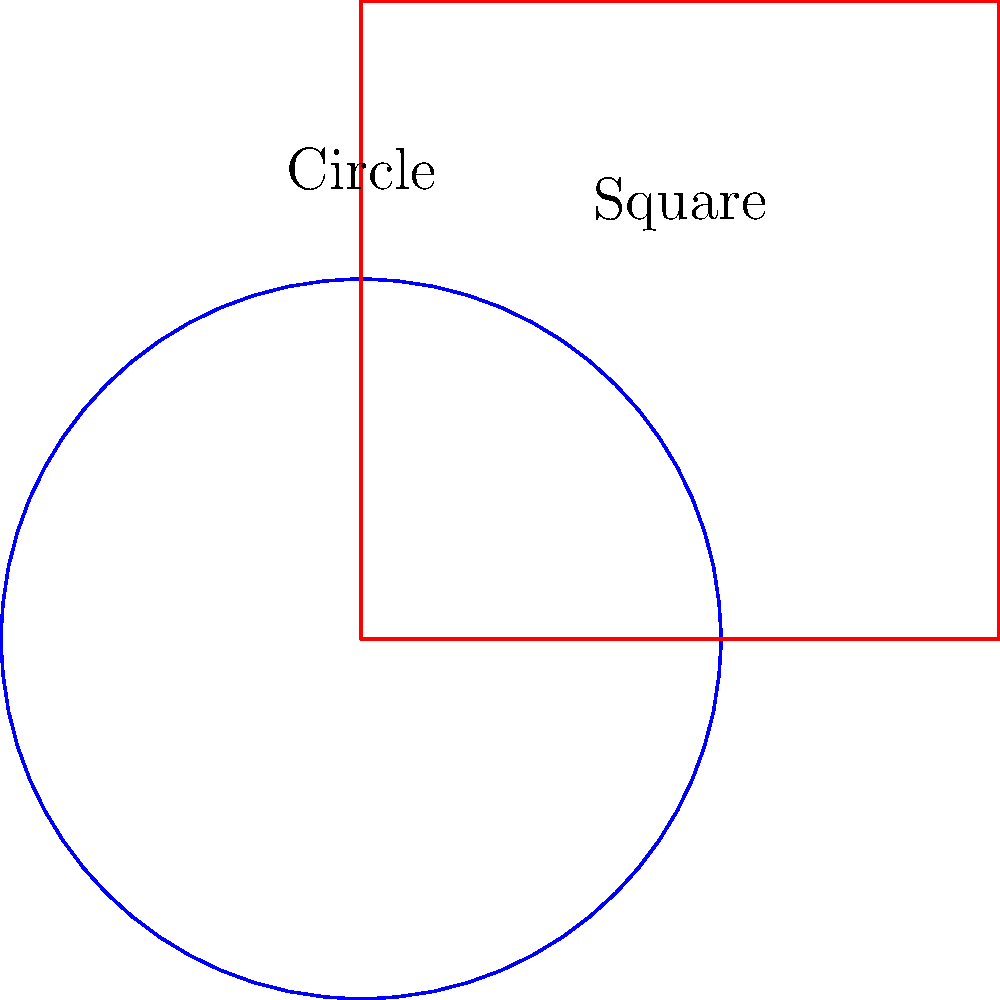Consider a circle and a square with equal areas, as shown in the figure. Are these two shapes homeomorphic? If so, describe a homeomorphism between them. To determine if the circle and square are homeomorphic, we need to consider the following steps:

1. Definition of homeomorphism: Two topological spaces are homeomorphic if there exists a continuous bijective function with a continuous inverse between them.

2. Properties of the circle and square:
   - Both are simple closed curves in the plane.
   - Both are compact and connected.
   - Both have no holes or punctures.

3. Intuitive understanding:
   - We can imagine stretching and deforming the circle into a square shape without tearing or creating holes.
   - This transformation can be done continuously and reversibly.

4. Formal homeomorphism:
   - We can define a homeomorphism $f: S^1 \rightarrow \partial [0,1]^2$, where $S^1$ is the unit circle and $\partial [0,1]^2$ is the boundary of the unit square.
   - One way to construct this homeomorphism is:
     $$f(x,y) = \begin{cases}
        (1, \frac{y}{x}) & \text{if } x > |y| \\
        (\frac{x}{y}, 1) & \text{if } y > |x| \\
        (-1, -\frac{y}{x}) & \text{if } x < -|y| \\
        (\frac{x}{y}, -1) & \text{if } y < -|x|
     \end{cases}$$

5. Properties of this homeomorphism:
   - It is continuous on the entire circle.
   - It is bijective (one-to-one and onto).
   - Its inverse is also continuous.

6. Conclusion:
   - Since we can establish a homeomorphism between the circle and the square, they are indeed homeomorphic.
Answer: Yes, homeomorphic. Continuous deformation without tearing. 